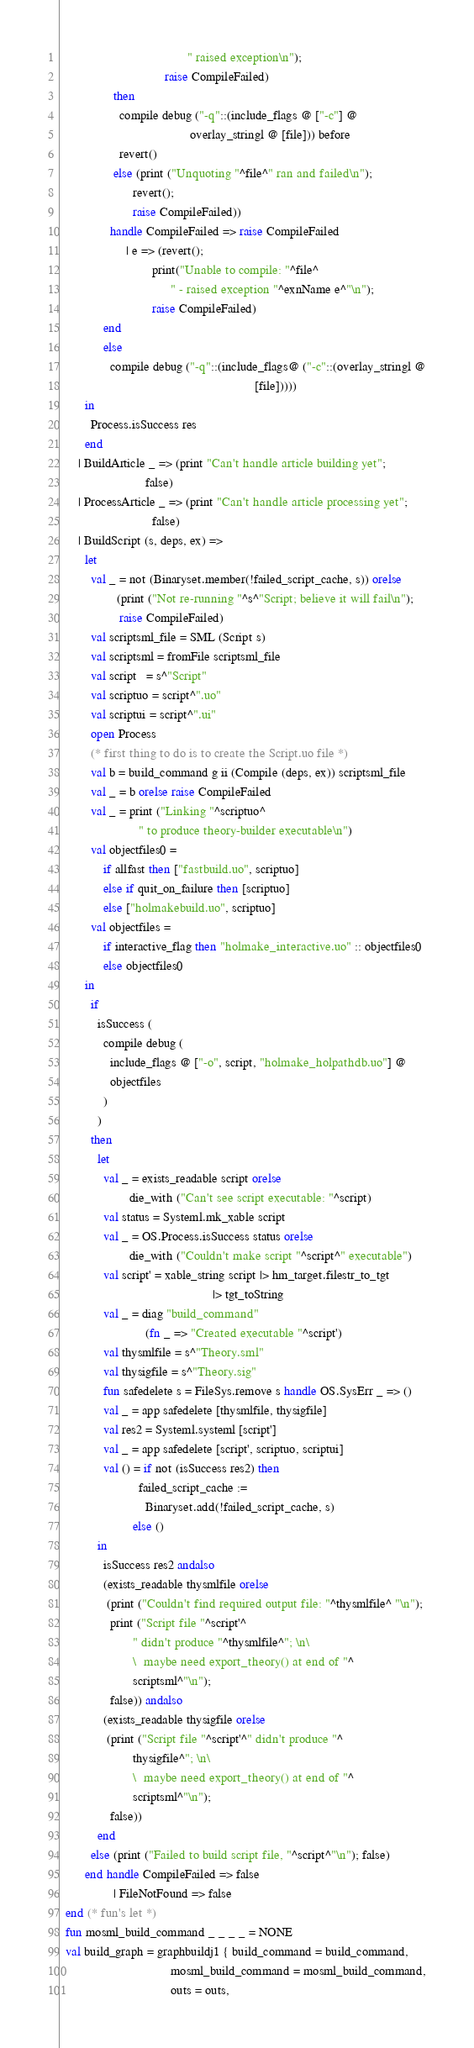<code> <loc_0><loc_0><loc_500><loc_500><_SML_>                                        " raised exception\n");
                                 raise CompileFailed)
                 then
                   compile debug ("-q"::(include_flags @ ["-c"] @
                                         overlay_stringl @ [file])) before
                   revert()
                 else (print ("Unquoting "^file^" ran and failed\n");
                       revert();
                       raise CompileFailed))
                handle CompileFailed => raise CompileFailed
                     | e => (revert();
                             print("Unable to compile: "^file^
                                   " - raised exception "^exnName e^"\n");
                             raise CompileFailed)
              end
              else
                compile debug ("-q"::(include_flags@ ("-c"::(overlay_stringl @
                                                             [file]))))
        in
          Process.isSuccess res
        end
      | BuildArticle _ => (print "Can't handle article building yet";
                           false)
      | ProcessArticle _ => (print "Can't handle article processing yet";
                             false)
      | BuildScript (s, deps, ex) =>
        let
          val _ = not (Binaryset.member(!failed_script_cache, s)) orelse
                  (print ("Not re-running "^s^"Script; believe it will fail\n");
                   raise CompileFailed)
          val scriptsml_file = SML (Script s)
          val scriptsml = fromFile scriptsml_file
          val script   = s^"Script"
          val scriptuo = script^".uo"
          val scriptui = script^".ui"
          open Process
          (* first thing to do is to create the Script.uo file *)
          val b = build_command g ii (Compile (deps, ex)) scriptsml_file
          val _ = b orelse raise CompileFailed
          val _ = print ("Linking "^scriptuo^
                         " to produce theory-builder executable\n")
          val objectfiles0 =
              if allfast then ["fastbuild.uo", scriptuo]
              else if quit_on_failure then [scriptuo]
              else ["holmakebuild.uo", scriptuo]
          val objectfiles =
              if interactive_flag then "holmake_interactive.uo" :: objectfiles0
              else objectfiles0
        in
          if
            isSuccess (
              compile debug (
                include_flags @ ["-o", script, "holmake_holpathdb.uo"] @
                objectfiles
              )
            )
          then
            let
              val _ = exists_readable script orelse
                      die_with ("Can't see script executable: "^script)
              val status = Systeml.mk_xable script
              val _ = OS.Process.isSuccess status orelse
                      die_with ("Couldn't make script "^script^" executable")
              val script' = xable_string script |> hm_target.filestr_to_tgt
                                                |> tgt_toString
              val _ = diag "build_command"
                           (fn _ => "Created executable "^script')
              val thysmlfile = s^"Theory.sml"
              val thysigfile = s^"Theory.sig"
              fun safedelete s = FileSys.remove s handle OS.SysErr _ => ()
              val _ = app safedelete [thysmlfile, thysigfile]
              val res2 = Systeml.systeml [script']
              val _ = app safedelete [script', scriptuo, scriptui]
              val () = if not (isSuccess res2) then
                         failed_script_cache :=
                           Binaryset.add(!failed_script_cache, s)
                       else ()
            in
              isSuccess res2 andalso
              (exists_readable thysmlfile orelse
               (print ("Couldn't find required output file: "^thysmlfile^ "\n");
                print ("Script file "^script'^
                       " didn't produce "^thysmlfile^"; \n\
                       \  maybe need export_theory() at end of "^
                       scriptsml^"\n");
                false)) andalso
              (exists_readable thysigfile orelse
               (print ("Script file "^script'^" didn't produce "^
                       thysigfile^"; \n\
                       \  maybe need export_theory() at end of "^
                       scriptsml^"\n");
                false))
            end
          else (print ("Failed to build script file, "^script^"\n"); false)
        end handle CompileFailed => false
                 | FileNotFound => false
  end (* fun's let *)
  fun mosml_build_command _ _ _ _ = NONE
  val build_graph = graphbuildj1 { build_command = build_command,
                                   mosml_build_command = mosml_build_command,
                                   outs = outs,</code> 